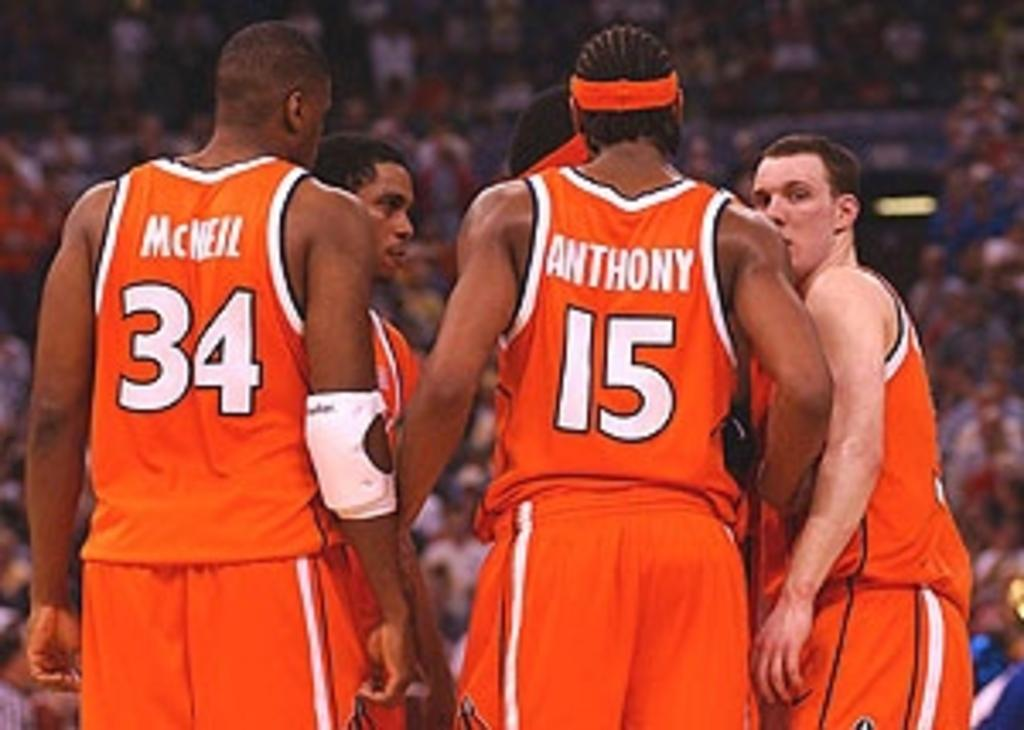What is the main subject of the image? The main subject of the image is a group of people. Where are the people located in the image? The people are standing on the ground. Can you describe the background of the image? There are persons visible in the background of the image. What type of sweater is the person in the background wearing? There is no information about a sweater or any specific clothing in the image. 